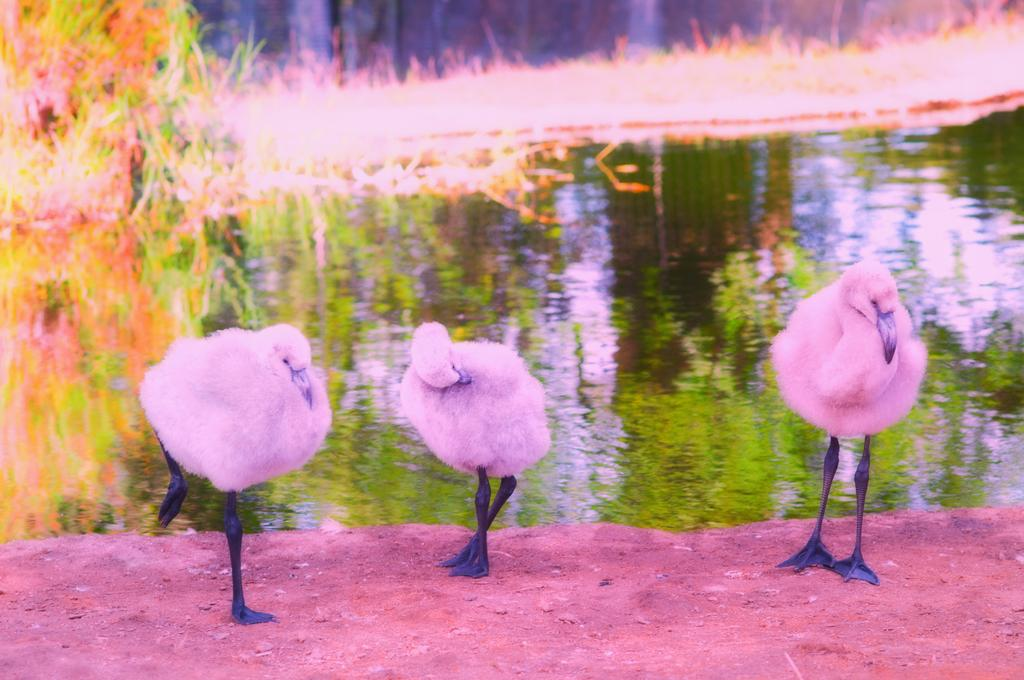What color are the birds in the image? The birds in the image are pink. What is the birds' position in the image? The birds are standing on the ground. What can be seen in the background of the image? Water, grass, and other objects are visible in the background of the image. How is the parcel being delivered by the birds in the image? There is no parcel present in the image, so it cannot be delivered by the birds. 